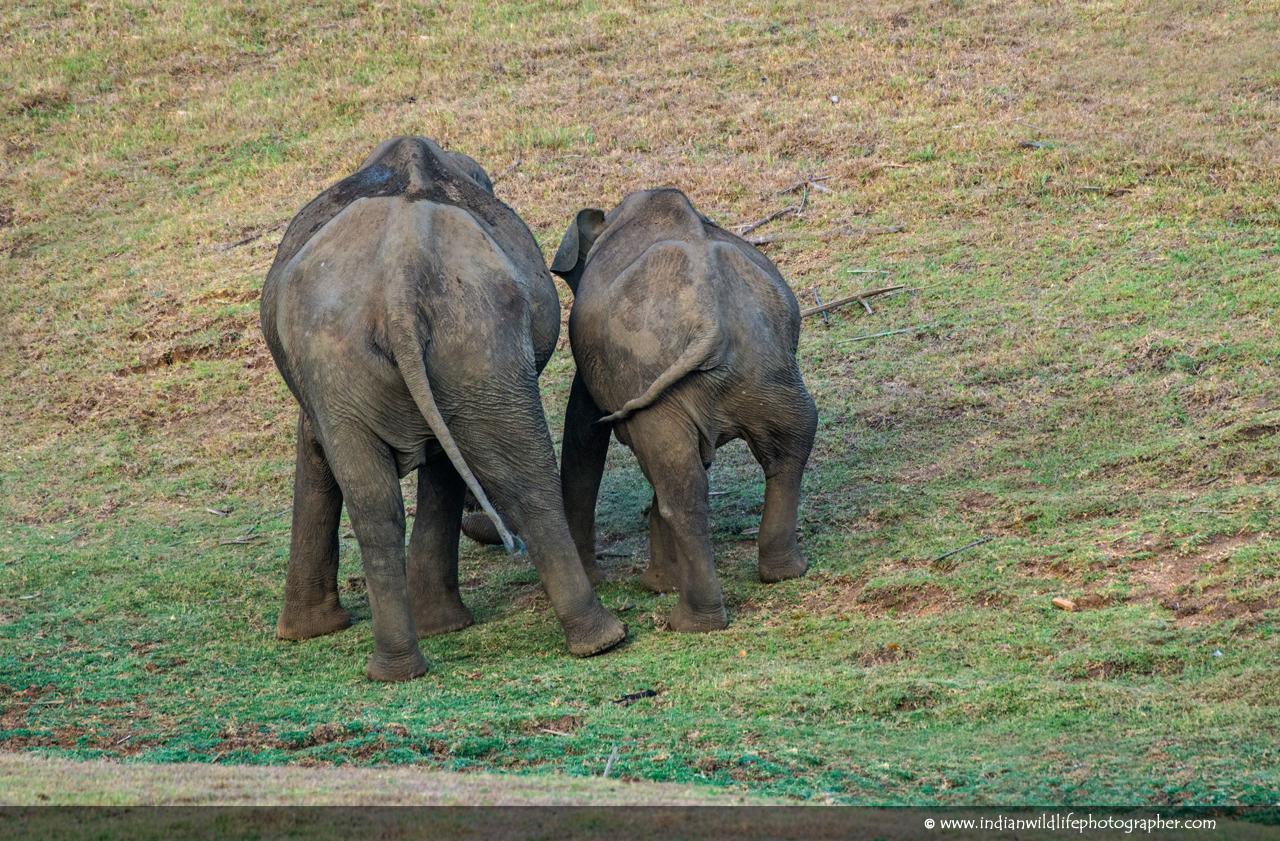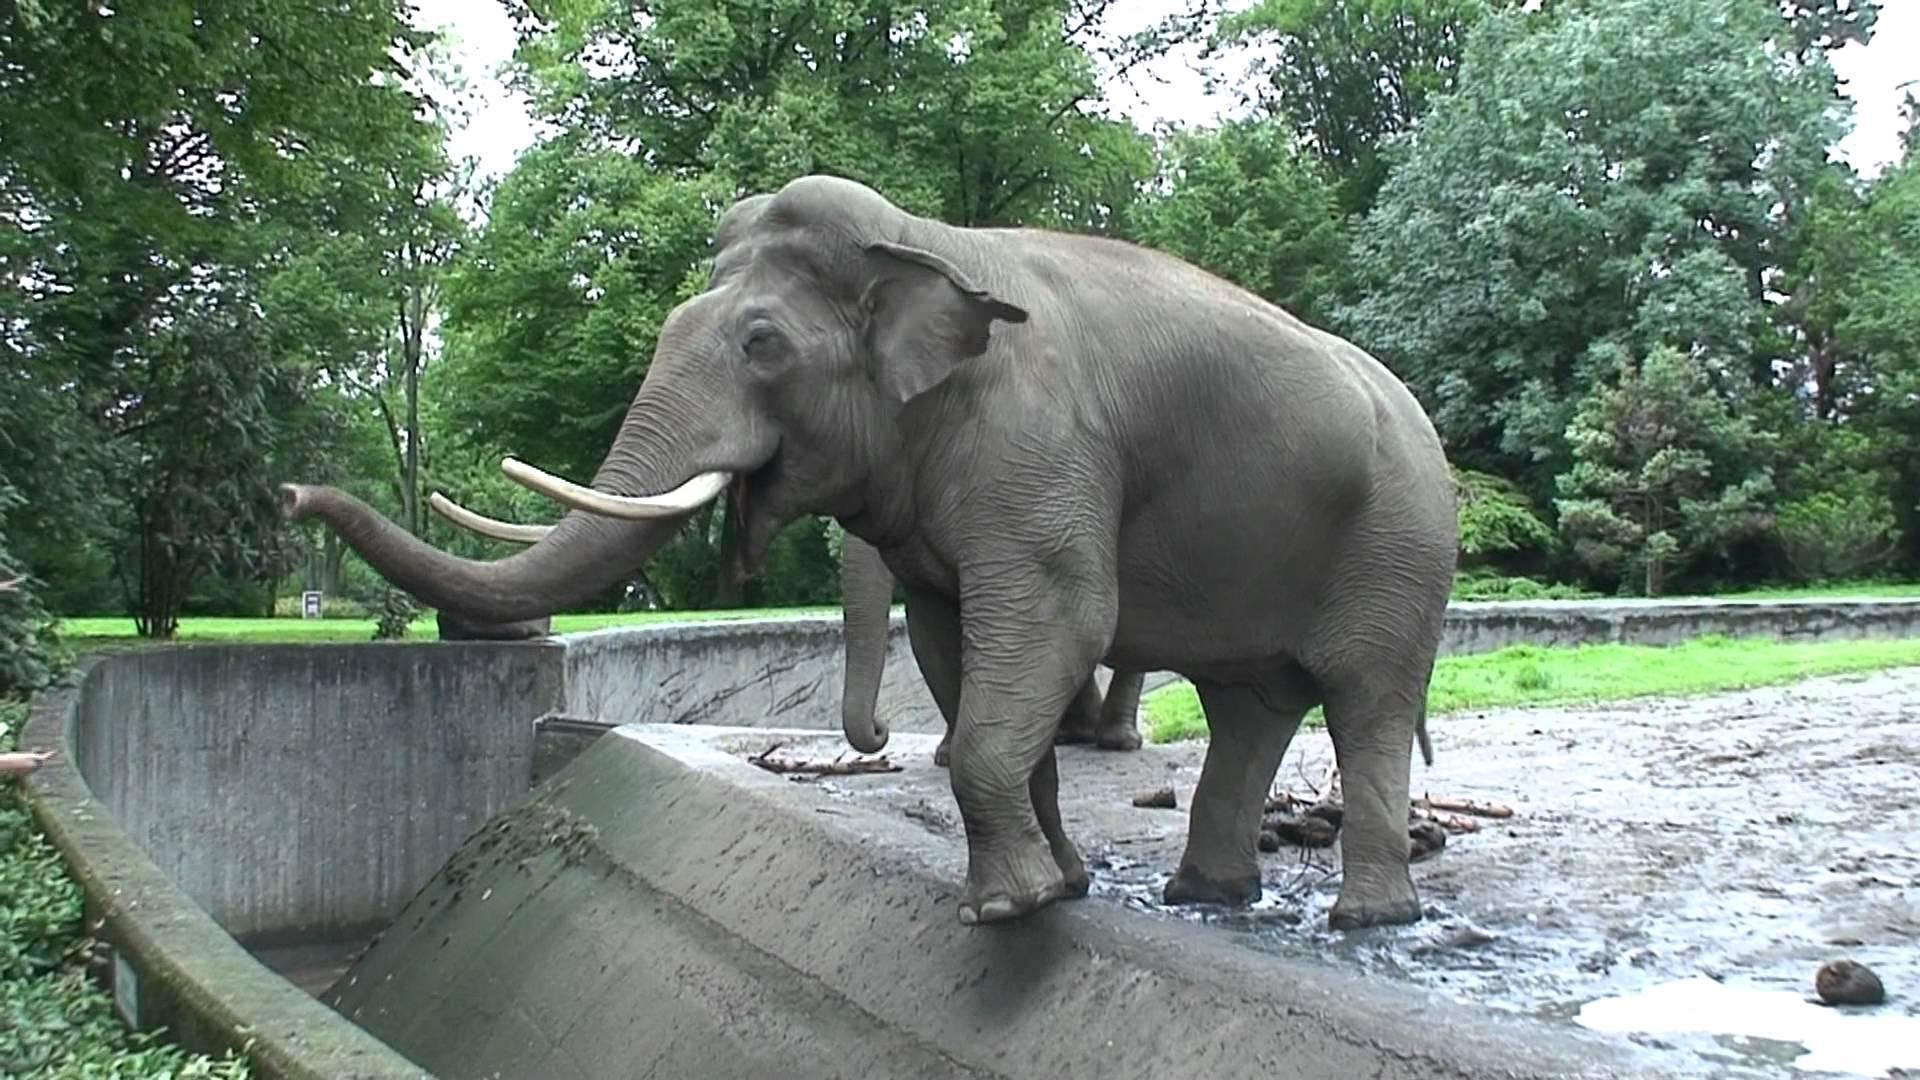The first image is the image on the left, the second image is the image on the right. For the images shown, is this caption "An image shows one small elephant with its head poking under the legs of an adult elephant with a curled trunk." true? Answer yes or no. No. The first image is the image on the left, the second image is the image on the right. For the images displayed, is the sentence "An elephant's trunk is curved up." factually correct? Answer yes or no. Yes. 